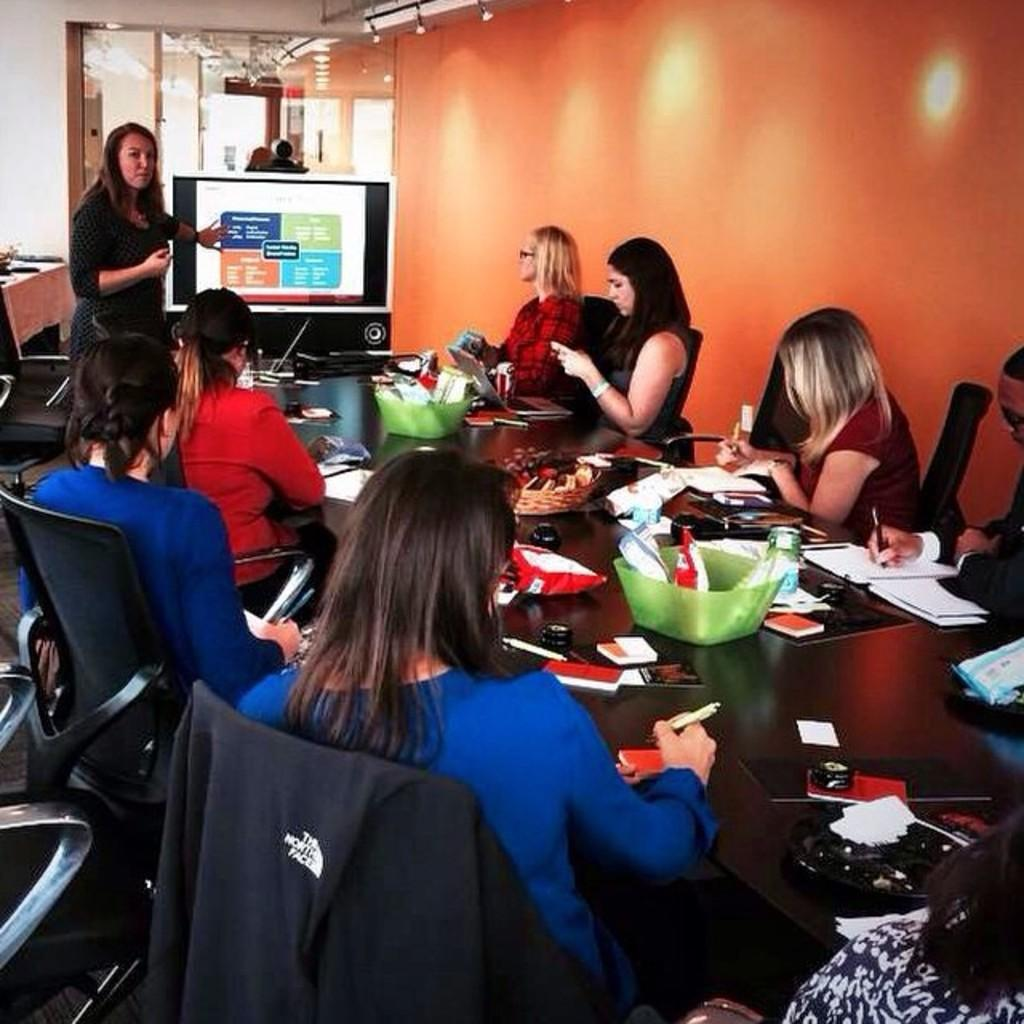What are the people in the image doing? The people in the image are sitting on chairs. What is on the table in the image? There is a bowl, spoons, and napkins on the table. What is the purpose of the spoons on the table? The spoons on the table are likely for eating or serving the contents of the bowl. What can be seen in the background of the image? There is a building visible in the image. What type of carriage is being used by the people in the image? There is no carriage present in the image. 